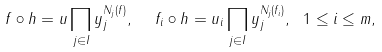Convert formula to latex. <formula><loc_0><loc_0><loc_500><loc_500>f \circ h = u \prod _ { j \in I } y _ { j } ^ { N _ { j } ( f ) } , \ \ f _ { i } \circ h = u _ { i } \prod _ { j \in I } y _ { j } ^ { N _ { j } ( f _ { i } ) } , \ 1 \leq i \leq m ,</formula> 